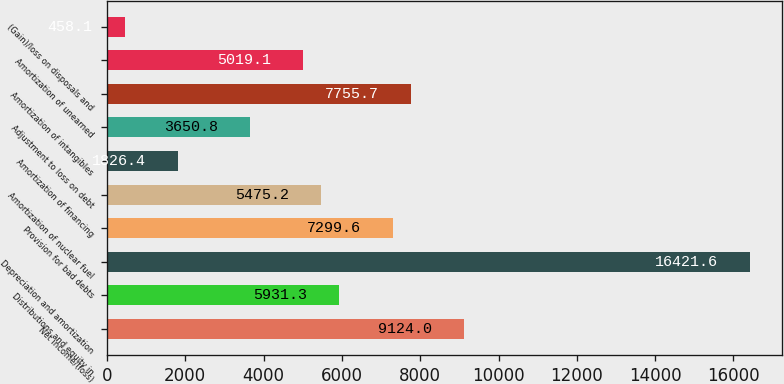<chart> <loc_0><loc_0><loc_500><loc_500><bar_chart><fcel>Net income/(loss)<fcel>Distributions and equity in<fcel>Depreciation and amortization<fcel>Provision for bad debts<fcel>Amortization of nuclear fuel<fcel>Amortization of financing<fcel>Adjustment to loss on debt<fcel>Amortization of intangibles<fcel>Amortization of unearned<fcel>(Gain)/loss on disposals and<nl><fcel>9124<fcel>5931.3<fcel>16421.6<fcel>7299.6<fcel>5475.2<fcel>1826.4<fcel>3650.8<fcel>7755.7<fcel>5019.1<fcel>458.1<nl></chart> 